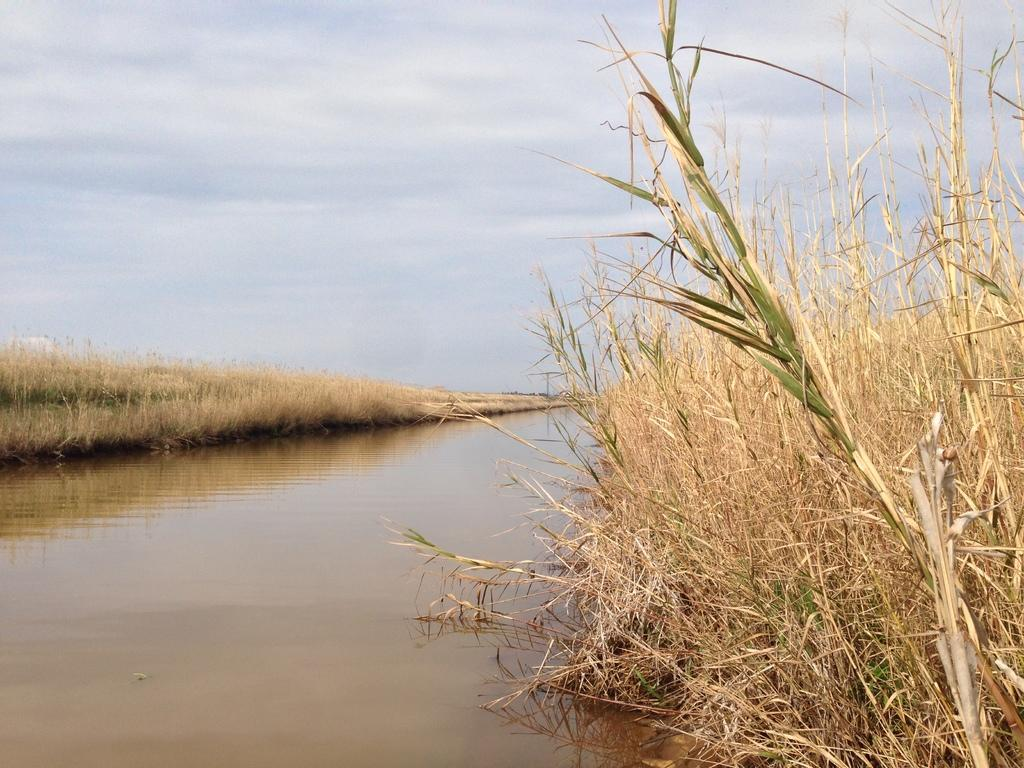What type of vegetation can be seen in the image? There is grass in the image. What else is present in the image besides grass? There is water in the image. What can be seen in the background of the image? The sky is visible in the background of the image. Where is the sister located in the image? There is no sister present in the image. What color is the heart in the image? There is no heart present in the image. 